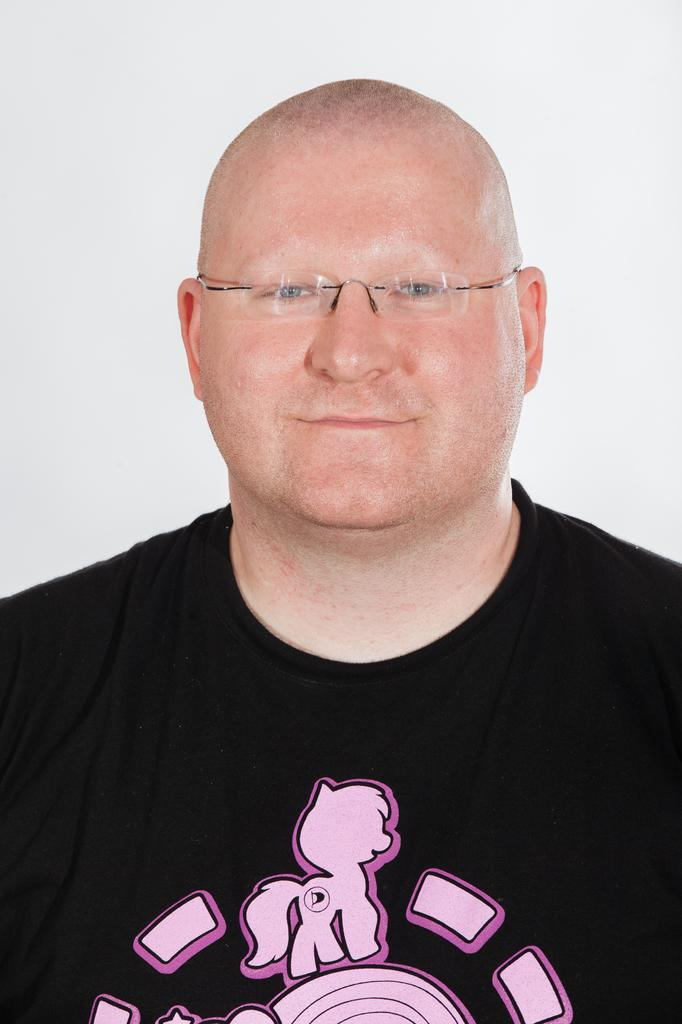Who is present in the image? There is a man in the image. What is the man wearing? The man is wearing a black T-shirt. What is the color of the background in the image? The background of the image is white. What type of basket is the man holding in the image? There is no basket present in the image; the man is not holding anything. 